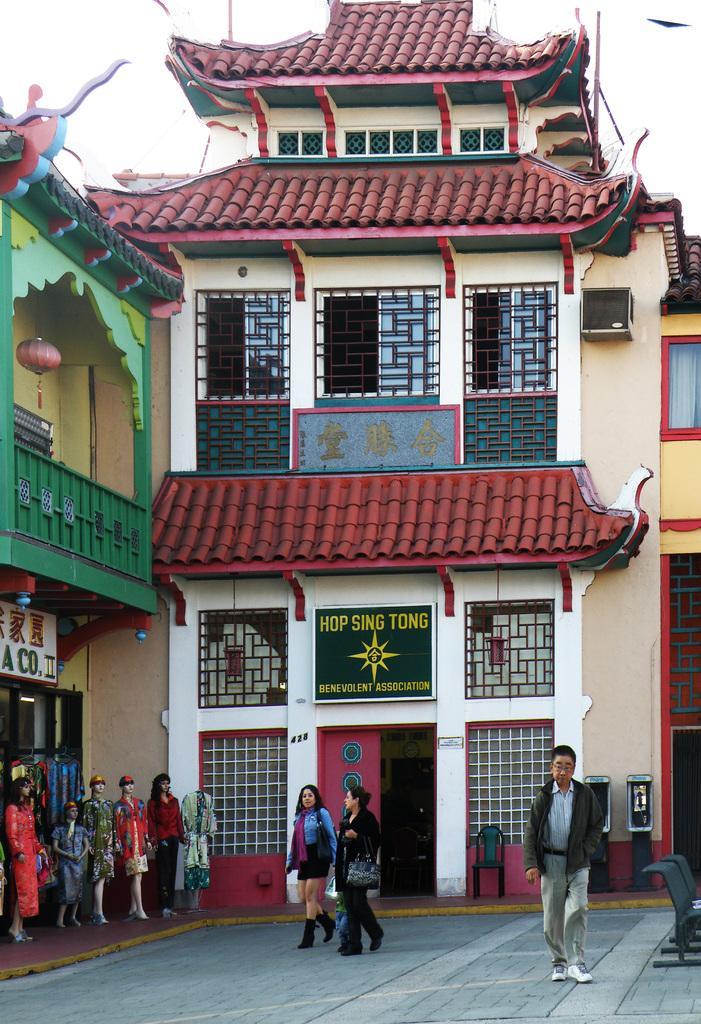How would you summarize this image in a sentence or two? In the background of the image there is a building with windows and door. There are people walking. At the bottom of the image there is floor. To the left side of the image there are mannequins. At the top of the image there is sky. 